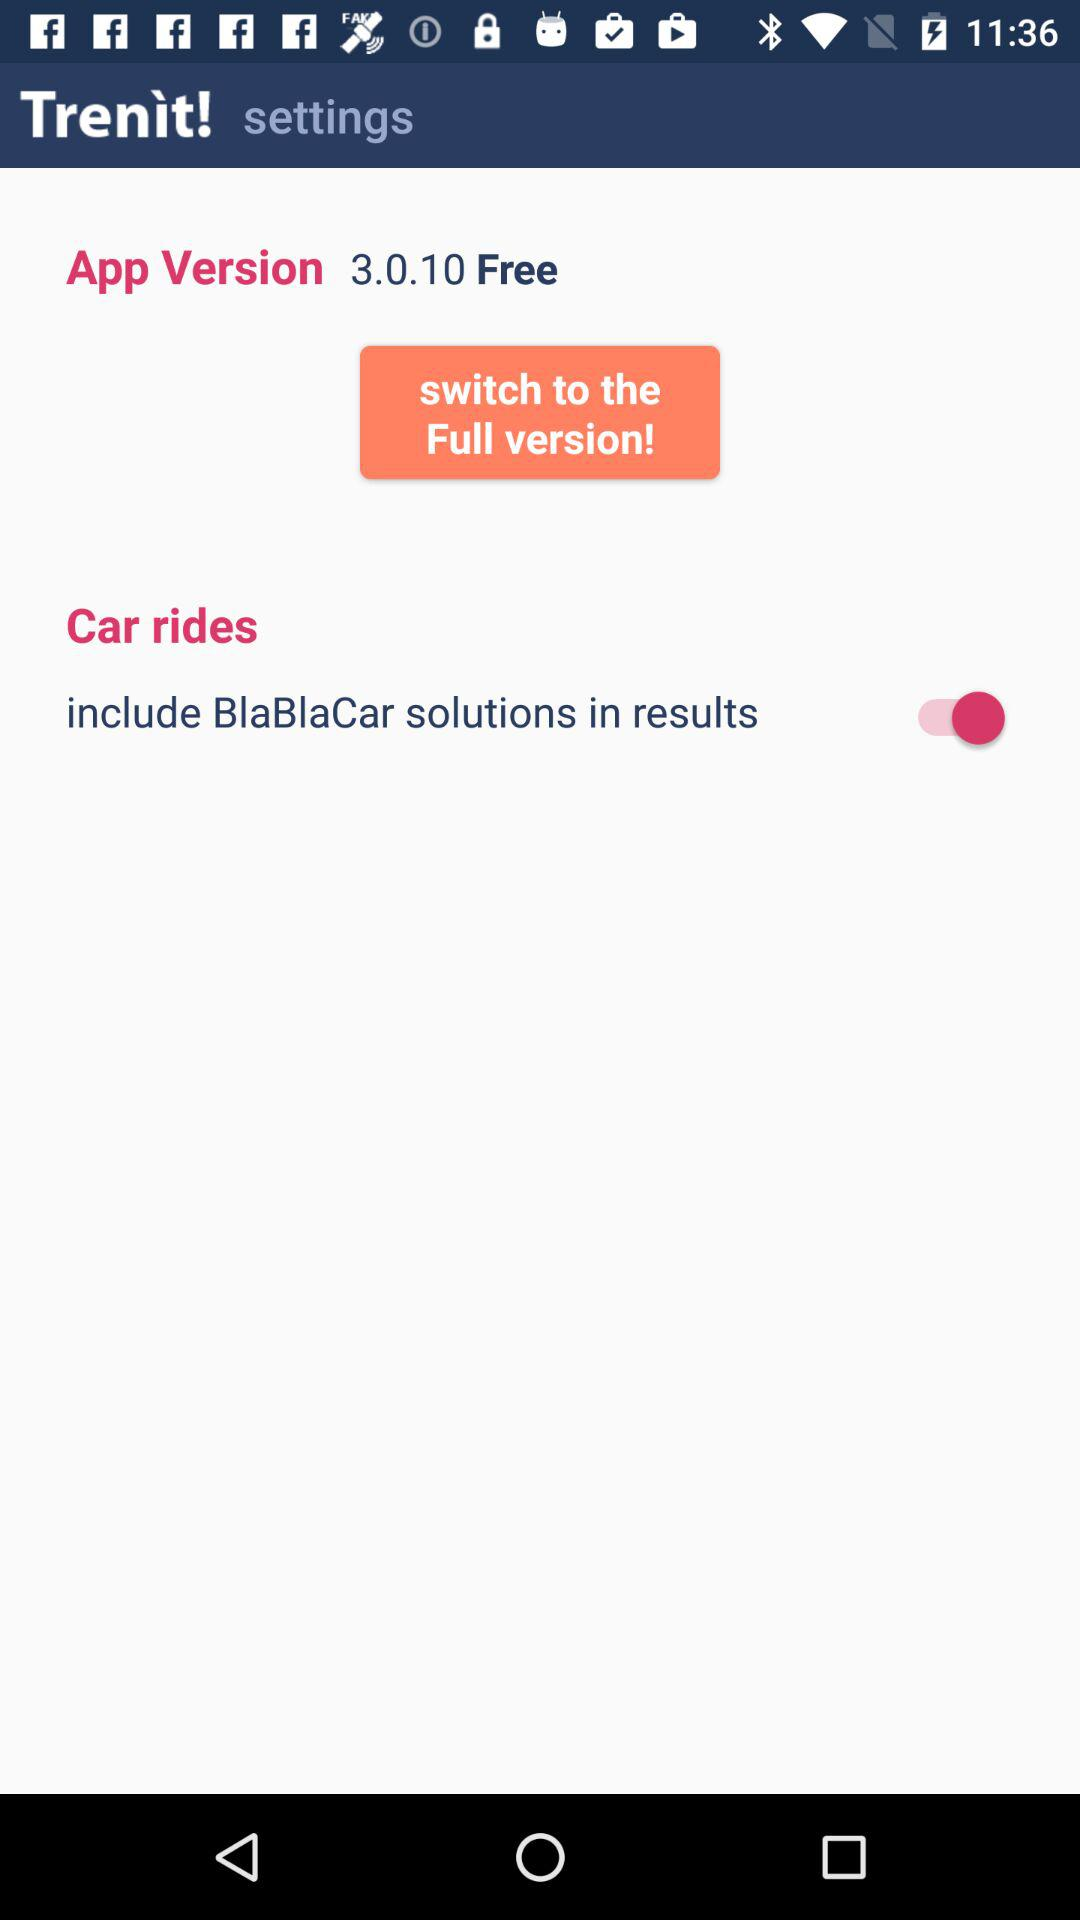What is the status of "Car rides"? The status is "on". 